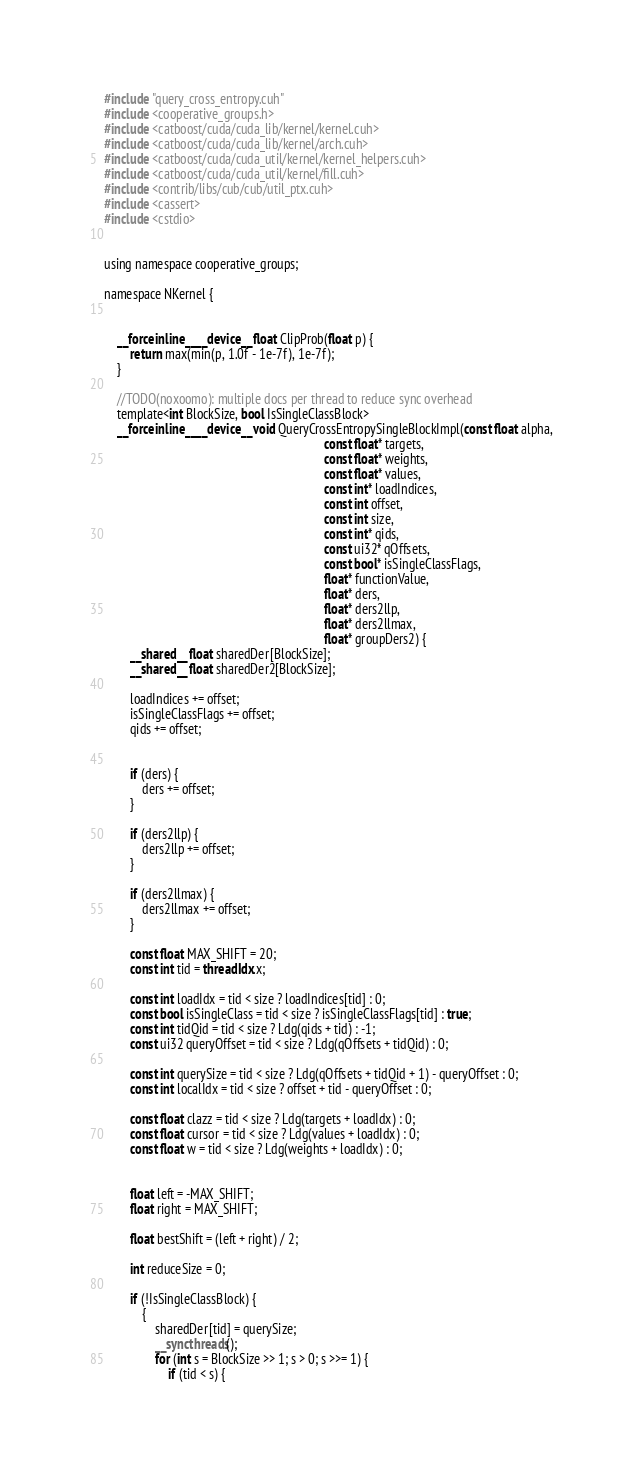Convert code to text. <code><loc_0><loc_0><loc_500><loc_500><_Cuda_>#include "query_cross_entropy.cuh"
#include <cooperative_groups.h>
#include <catboost/cuda/cuda_lib/kernel/kernel.cuh>
#include <catboost/cuda/cuda_lib/kernel/arch.cuh>
#include <catboost/cuda/cuda_util/kernel/kernel_helpers.cuh>
#include <catboost/cuda/cuda_util/kernel/fill.cuh>
#include <contrib/libs/cub/cub/util_ptx.cuh>
#include <cassert>
#include <cstdio>


using namespace cooperative_groups;

namespace NKernel {


    __forceinline__ __device__ float ClipProb(float p) {
        return max(min(p, 1.0f - 1e-7f), 1e-7f);
    }

    //TODO(noxoomo): multiple docs per thread to reduce sync overhead
    template<int BlockSize, bool IsSingleClassBlock>
    __forceinline__ __device__ void QueryCrossEntropySingleBlockImpl(const float alpha,
                                                                     const float* targets,
                                                                     const float* weights,
                                                                     const float* values,
                                                                     const int* loadIndices,
                                                                     const int offset,
                                                                     const int size,
                                                                     const int* qids,
                                                                     const ui32* qOffsets,
                                                                     const bool* isSingleClassFlags,
                                                                     float* functionValue,
                                                                     float* ders,
                                                                     float* ders2llp,
                                                                     float* ders2llmax,
                                                                     float* groupDers2) {
        __shared__ float sharedDer[BlockSize];
        __shared__ float sharedDer2[BlockSize];

        loadIndices += offset;
        isSingleClassFlags += offset;
        qids += offset;


        if (ders) {
            ders += offset;
        }

        if (ders2llp) {
            ders2llp += offset;
        }

        if (ders2llmax) {
            ders2llmax += offset;
        }

        const float MAX_SHIFT = 20;
        const int tid = threadIdx.x;

        const int loadIdx = tid < size ? loadIndices[tid] : 0;
        const bool isSingleClass = tid < size ? isSingleClassFlags[tid] : true;
        const int tidQid = tid < size ? Ldg(qids + tid) : -1;
        const ui32 queryOffset = tid < size ? Ldg(qOffsets + tidQid) : 0;

        const int querySize = tid < size ? Ldg(qOffsets + tidQid + 1) - queryOffset : 0;
        const int localIdx = tid < size ? offset + tid - queryOffset : 0;

        const float clazz = tid < size ? Ldg(targets + loadIdx) : 0;
        const float cursor = tid < size ? Ldg(values + loadIdx) : 0;
        const float w = tid < size ? Ldg(weights + loadIdx) : 0;


        float left = -MAX_SHIFT;
        float right = MAX_SHIFT;

        float bestShift = (left + right) / 2;

        int reduceSize = 0;

        if (!IsSingleClassBlock) {
            {
                sharedDer[tid] = querySize;
                __syncthreads();
                for (int s = BlockSize >> 1; s > 0; s >>= 1) {
                    if (tid < s) {</code> 